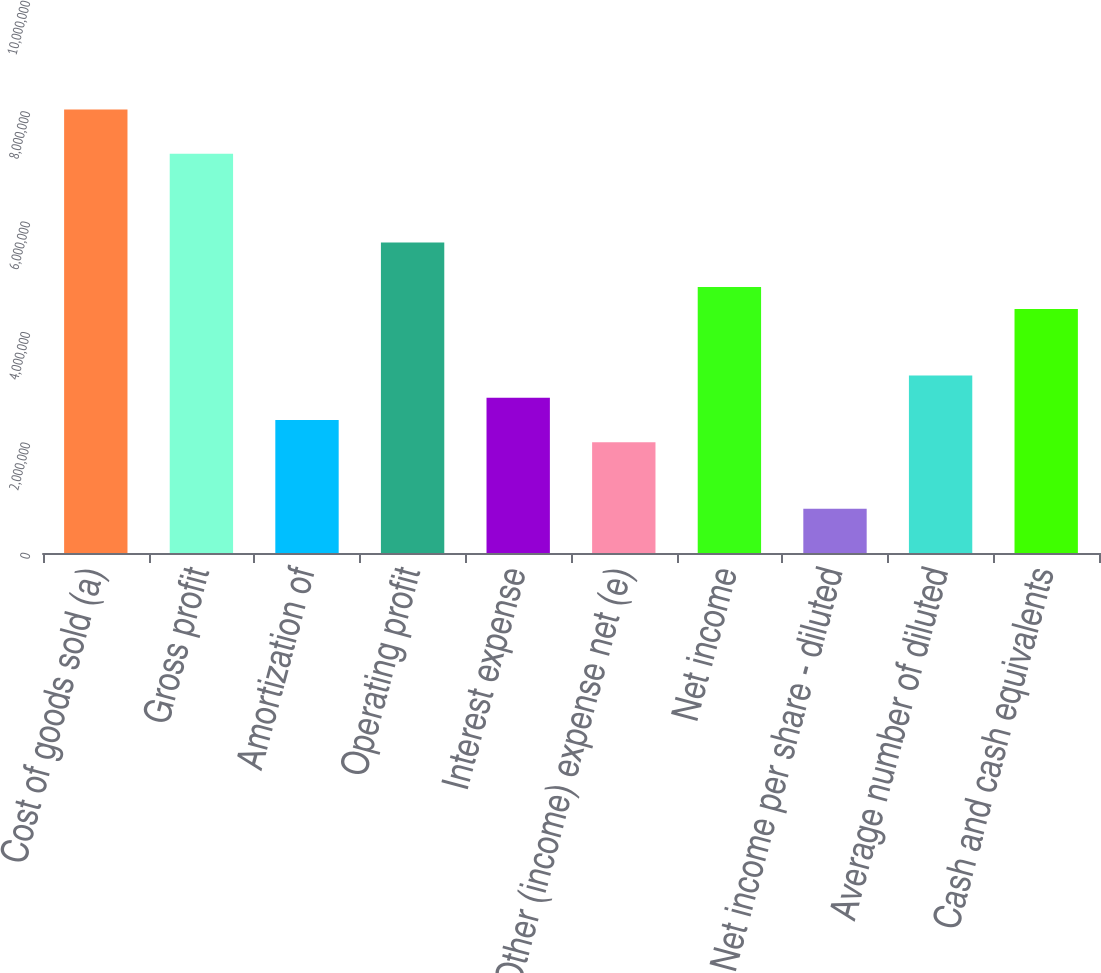<chart> <loc_0><loc_0><loc_500><loc_500><bar_chart><fcel>Cost of goods sold (a)<fcel>Gross profit<fcel>Amortization of<fcel>Operating profit<fcel>Interest expense<fcel>Other (income) expense net (e)<fcel>Net income<fcel>Net income per share - diluted<fcel>Average number of diluted<fcel>Cash and cash equivalents<nl><fcel>8.03397e+06<fcel>7.23057e+06<fcel>2.41019e+06<fcel>5.62378e+06<fcel>2.81189e+06<fcel>2.00849e+06<fcel>4.82038e+06<fcel>803398<fcel>3.21359e+06<fcel>4.41868e+06<nl></chart> 